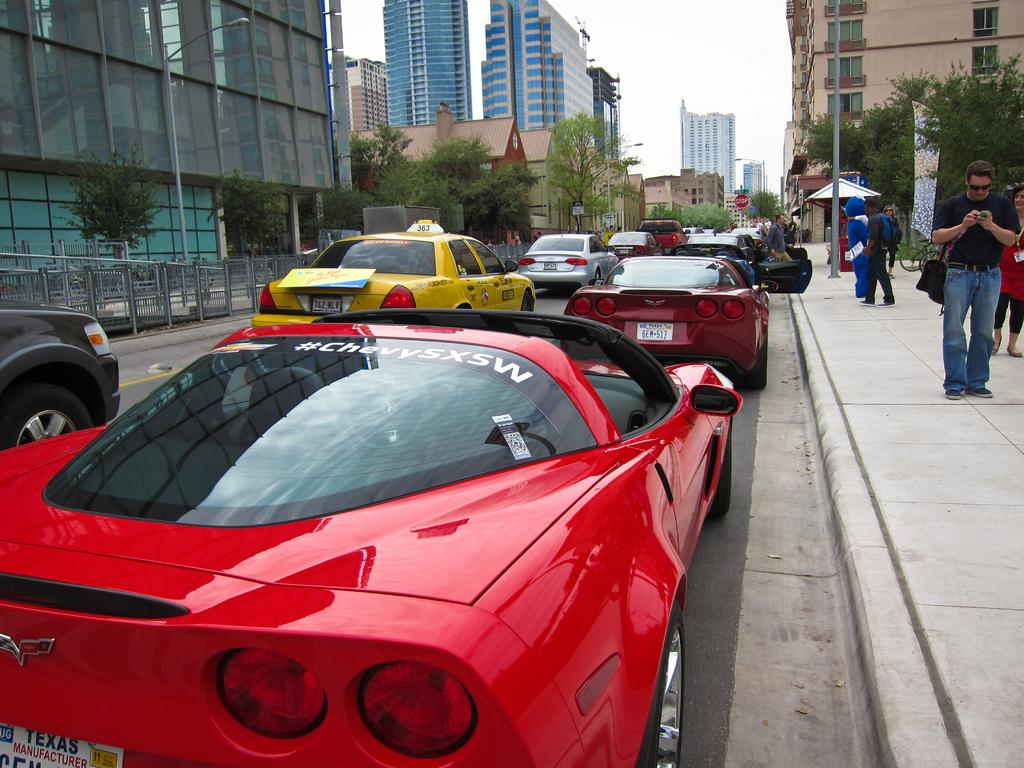<image>
Create a compact narrative representing the image presented. A shiny red Chevy sports car with a Texas license plate. 